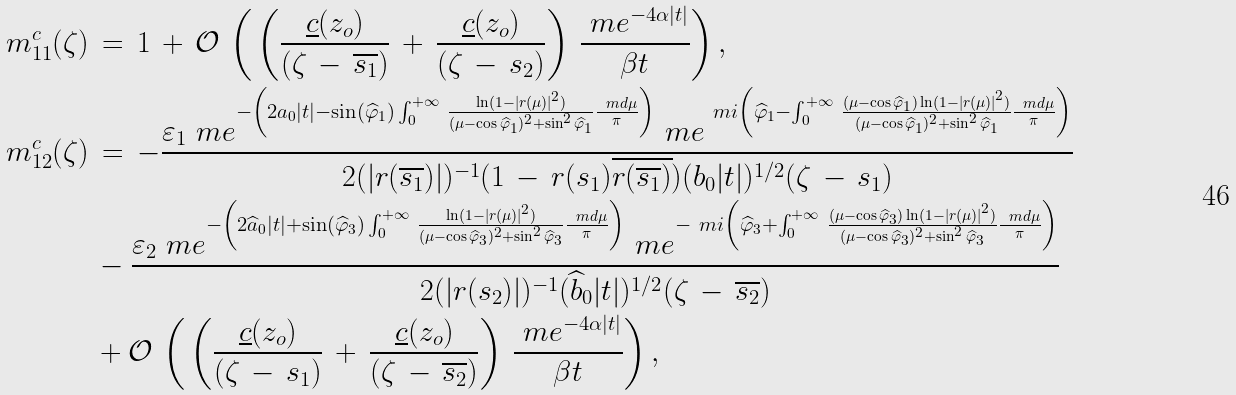Convert formula to latex. <formula><loc_0><loc_0><loc_500><loc_500>m ^ { c } _ { 1 1 } ( \zeta ) \, & = \, 1 \, + \, \mathcal { O } \, \left ( \, \left ( \frac { \underline { c } ( z _ { o } ) } { ( \zeta \, - \, \overline { s _ { 1 } } ) } \, + \, \frac { \underline { c } ( z _ { o } ) } { ( \zeta \, - \, s _ { 2 } ) } \right ) \, \frac { \ m e ^ { - 4 \alpha | t | } } { \beta t } \right ) , \\ m ^ { c } _ { 1 2 } ( \zeta ) \, & = \, - \frac { \varepsilon _ { 1 } \ m e ^ { - \left ( 2 a _ { 0 } | t | - \sin ( \widehat { \varphi } _ { 1 } ) \int _ { 0 } ^ { + \infty } \, \frac { \ln ( 1 - | r ( \mu ) | ^ { 2 } ) } { ( \mu - \cos \widehat { \varphi } _ { 1 } ) ^ { 2 } + \sin ^ { 2 } \widehat { \varphi } _ { 1 } } \frac { \ m d \mu } { \pi } \right ) } \ m e ^ { \ m i \left ( \widehat { \varphi } _ { 1 } - \int _ { 0 } ^ { + \infty } \, \frac { ( \mu - \cos \widehat { \varphi } _ { 1 } ) \ln ( 1 - | r ( \mu ) | ^ { 2 } ) } { ( \mu - \cos \widehat { \varphi } _ { 1 } ) ^ { 2 } + \sin ^ { 2 } \widehat { \varphi } _ { 1 } } \frac { \ m d \mu } { \pi } \right ) } } { 2 ( | r ( \overline { s _ { 1 } } ) | ) ^ { - 1 } ( 1 \, - \, r ( s _ { 1 } ) \overline { r ( \overline { s _ { 1 } } ) } ) ( b _ { 0 } | t | ) ^ { 1 / 2 } ( \zeta \, - \, s _ { 1 } ) } \\ & - \frac { \varepsilon _ { 2 } \ m e ^ { - \left ( 2 \widehat { a } _ { 0 } | t | + \sin ( \widehat { \varphi } _ { 3 } ) \int _ { 0 } ^ { + \infty } \, \frac { \ln ( 1 - | r ( \mu ) | ^ { 2 } ) } { ( \mu - \cos \widehat { \varphi } _ { 3 } ) ^ { 2 } + \sin ^ { 2 } \widehat { \varphi } _ { 3 } } \frac { \ m d \mu } { \pi } \right ) } \ m e ^ { - \ m i \left ( \widehat { \varphi } _ { 3 } + \int _ { 0 } ^ { + \infty } \, \frac { ( \mu - \cos \widehat { \varphi } _ { 3 } ) \ln ( 1 - | r ( \mu ) | ^ { 2 } ) } { ( \mu - \cos \widehat { \varphi } _ { 3 } ) ^ { 2 } + \sin ^ { 2 } \widehat { \varphi } _ { 3 } } \frac { \ m d \mu } { \pi } \right ) } } { 2 ( | r ( s _ { 2 } ) | ) ^ { - 1 } ( \widehat { b } _ { 0 } | t | ) ^ { 1 / 2 } ( \zeta \, - \, \overline { s _ { 2 } } ) } \\ & + \mathcal { O } \, \left ( \, \left ( \frac { \underline { c } ( z _ { o } ) } { ( \zeta \, - \, s _ { 1 } ) } \, + \, \frac { \underline { c } ( z _ { o } ) } { ( \zeta \, - \, \overline { s _ { 2 } } ) } \right ) \, \frac { \ m e ^ { - 4 \alpha | t | } } { \beta t } \right ) ,</formula> 